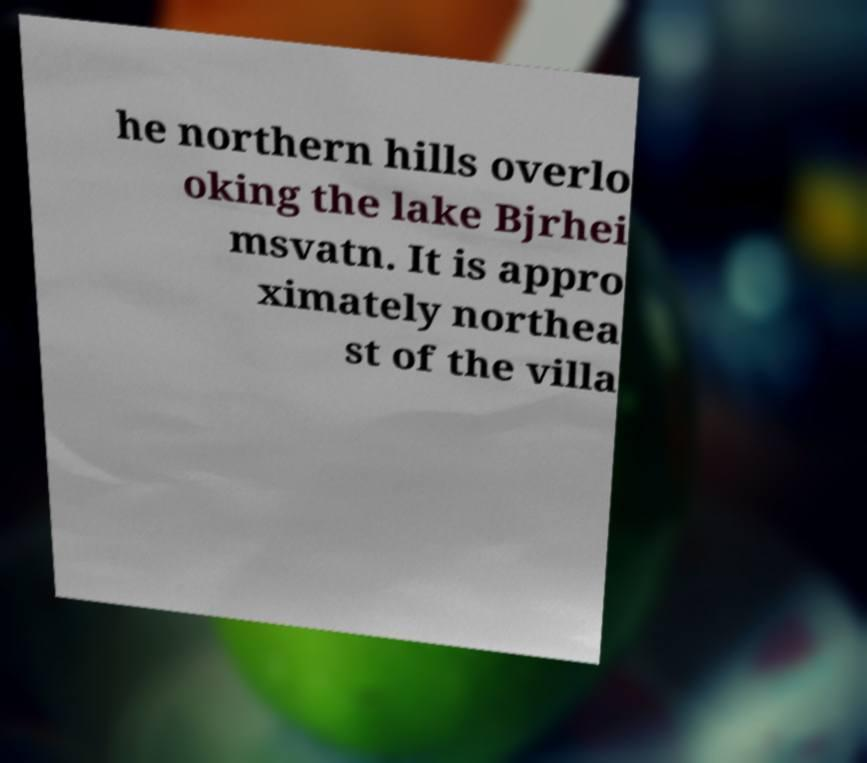Please identify and transcribe the text found in this image. he northern hills overlo oking the lake Bjrhei msvatn. It is appro ximately northea st of the villa 